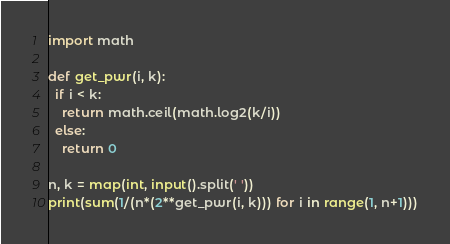Convert code to text. <code><loc_0><loc_0><loc_500><loc_500><_Python_>import math

def get_pwr(i, k):
  if i < k:
    return math.ceil(math.log2(k/i))
  else:
    return 0

n, k = map(int, input().split(' '))
print(sum(1/(n*(2**get_pwr(i, k))) for i in range(1, n+1)))
</code> 